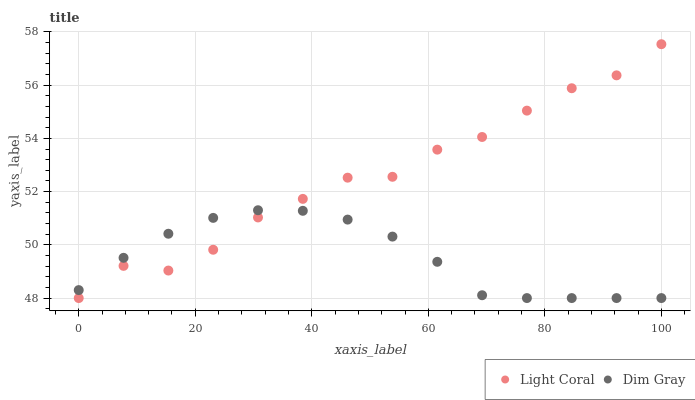Does Dim Gray have the minimum area under the curve?
Answer yes or no. Yes. Does Light Coral have the maximum area under the curve?
Answer yes or no. Yes. Does Dim Gray have the maximum area under the curve?
Answer yes or no. No. Is Dim Gray the smoothest?
Answer yes or no. Yes. Is Light Coral the roughest?
Answer yes or no. Yes. Is Dim Gray the roughest?
Answer yes or no. No. Does Light Coral have the lowest value?
Answer yes or no. Yes. Does Light Coral have the highest value?
Answer yes or no. Yes. Does Dim Gray have the highest value?
Answer yes or no. No. Does Light Coral intersect Dim Gray?
Answer yes or no. Yes. Is Light Coral less than Dim Gray?
Answer yes or no. No. Is Light Coral greater than Dim Gray?
Answer yes or no. No. 